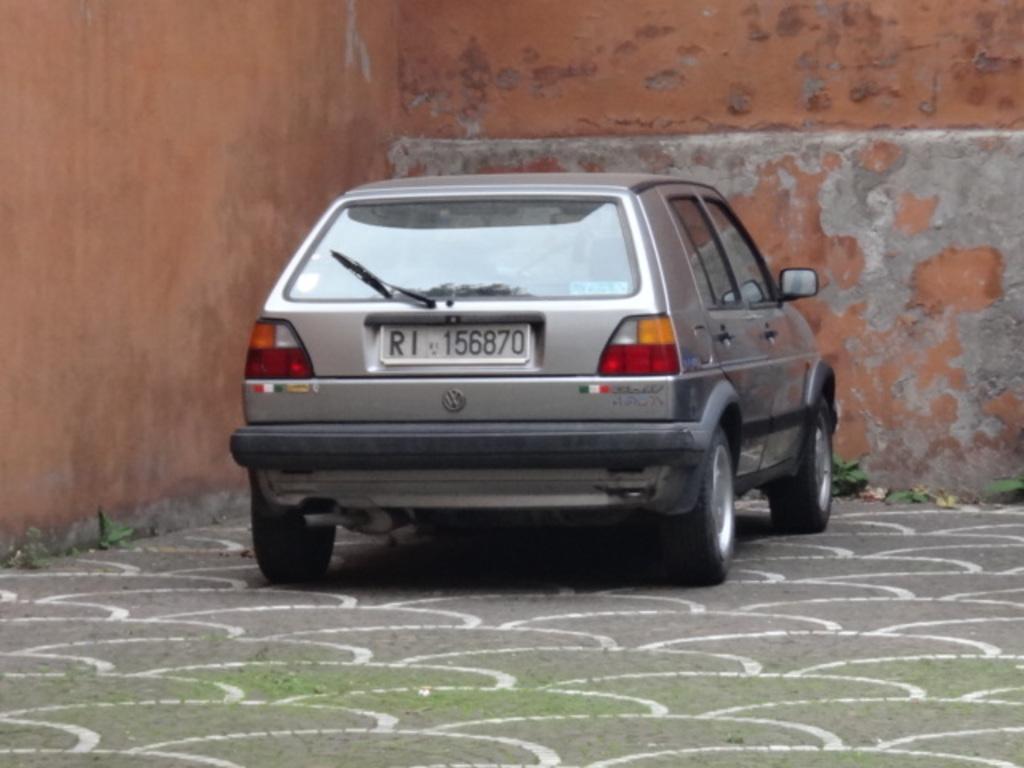Could you give a brief overview of what you see in this image? In this picture in the center there is a car on the road and in the background there is wall. 